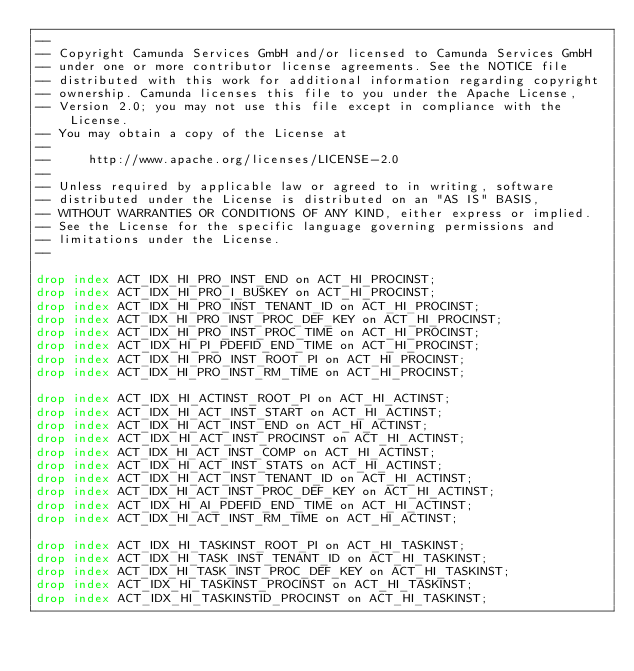<code> <loc_0><loc_0><loc_500><loc_500><_SQL_>--
-- Copyright Camunda Services GmbH and/or licensed to Camunda Services GmbH
-- under one or more contributor license agreements. See the NOTICE file
-- distributed with this work for additional information regarding copyright
-- ownership. Camunda licenses this file to you under the Apache License,
-- Version 2.0; you may not use this file except in compliance with the License.
-- You may obtain a copy of the License at
--
--     http://www.apache.org/licenses/LICENSE-2.0
--
-- Unless required by applicable law or agreed to in writing, software
-- distributed under the License is distributed on an "AS IS" BASIS,
-- WITHOUT WARRANTIES OR CONDITIONS OF ANY KIND, either express or implied.
-- See the License for the specific language governing permissions and
-- limitations under the License.
--

drop index ACT_IDX_HI_PRO_INST_END on ACT_HI_PROCINST;
drop index ACT_IDX_HI_PRO_I_BUSKEY on ACT_HI_PROCINST;
drop index ACT_IDX_HI_PRO_INST_TENANT_ID on ACT_HI_PROCINST;
drop index ACT_IDX_HI_PRO_INST_PROC_DEF_KEY on ACT_HI_PROCINST;
drop index ACT_IDX_HI_PRO_INST_PROC_TIME on ACT_HI_PROCINST;
drop index ACT_IDX_HI_PI_PDEFID_END_TIME on ACT_HI_PROCINST;
drop index ACT_IDX_HI_PRO_INST_ROOT_PI on ACT_HI_PROCINST;
drop index ACT_IDX_HI_PRO_INST_RM_TIME on ACT_HI_PROCINST;

drop index ACT_IDX_HI_ACTINST_ROOT_PI on ACT_HI_ACTINST;
drop index ACT_IDX_HI_ACT_INST_START on ACT_HI_ACTINST;
drop index ACT_IDX_HI_ACT_INST_END on ACT_HI_ACTINST;
drop index ACT_IDX_HI_ACT_INST_PROCINST on ACT_HI_ACTINST;
drop index ACT_IDX_HI_ACT_INST_COMP on ACT_HI_ACTINST;
drop index ACT_IDX_HI_ACT_INST_STATS on ACT_HI_ACTINST;
drop index ACT_IDX_HI_ACT_INST_TENANT_ID on ACT_HI_ACTINST;
drop index ACT_IDX_HI_ACT_INST_PROC_DEF_KEY on ACT_HI_ACTINST;
drop index ACT_IDX_HI_AI_PDEFID_END_TIME on ACT_HI_ACTINST;
drop index ACT_IDX_HI_ACT_INST_RM_TIME on ACT_HI_ACTINST;

drop index ACT_IDX_HI_TASKINST_ROOT_PI on ACT_HI_TASKINST;
drop index ACT_IDX_HI_TASK_INST_TENANT_ID on ACT_HI_TASKINST;
drop index ACT_IDX_HI_TASK_INST_PROC_DEF_KEY on ACT_HI_TASKINST;
drop index ACT_IDX_HI_TASKINST_PROCINST on ACT_HI_TASKINST;
drop index ACT_IDX_HI_TASKINSTID_PROCINST on ACT_HI_TASKINST;</code> 